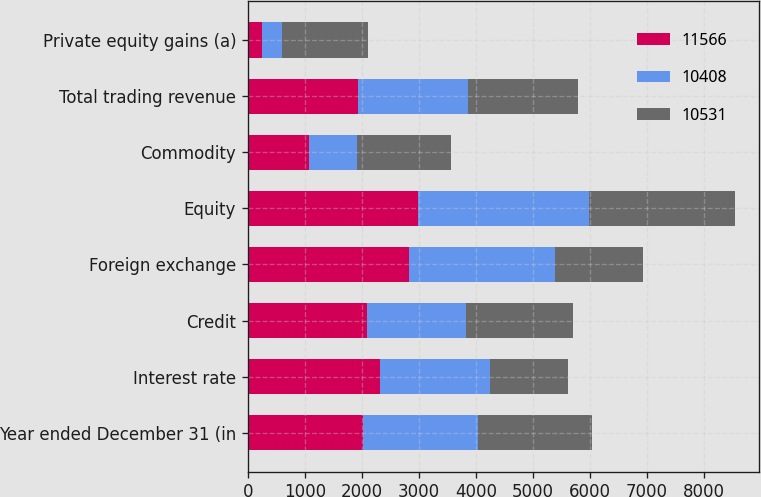Convert chart to OTSL. <chart><loc_0><loc_0><loc_500><loc_500><stacked_bar_chart><ecel><fcel>Year ended December 31 (in<fcel>Interest rate<fcel>Credit<fcel>Foreign exchange<fcel>Equity<fcel>Commodity<fcel>Total trading revenue<fcel>Private equity gains (a)<nl><fcel>11566<fcel>2016<fcel>2325<fcel>2096<fcel>2827<fcel>2994<fcel>1067<fcel>1933<fcel>257<nl><fcel>10408<fcel>2015<fcel>1933<fcel>1735<fcel>2557<fcel>2990<fcel>842<fcel>1933<fcel>351<nl><fcel>10531<fcel>2014<fcel>1362<fcel>1880<fcel>1556<fcel>2563<fcel>1663<fcel>1933<fcel>1507<nl></chart> 